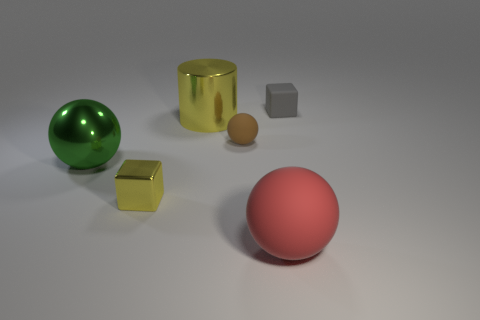Is the material of the cylinder the same as the small gray thing?
Provide a succinct answer. No. How many other objects are the same color as the small metallic thing?
Offer a very short reply. 1. Is the number of big things greater than the number of brown things?
Offer a terse response. Yes. Does the yellow metal cube have the same size as the metal object to the right of the tiny metal thing?
Ensure brevity in your answer.  No. There is a matte object that is left of the red ball; what color is it?
Provide a short and direct response. Brown. How many brown objects are either small cubes or big matte things?
Offer a terse response. 0. What color is the big cylinder?
Offer a very short reply. Yellow. Is the number of yellow cubes in front of the cylinder less than the number of red matte balls behind the tiny gray object?
Make the answer very short. No. The rubber thing that is to the right of the small brown sphere and in front of the gray thing has what shape?
Ensure brevity in your answer.  Sphere. How many brown objects have the same shape as the big yellow metallic object?
Keep it short and to the point. 0. 